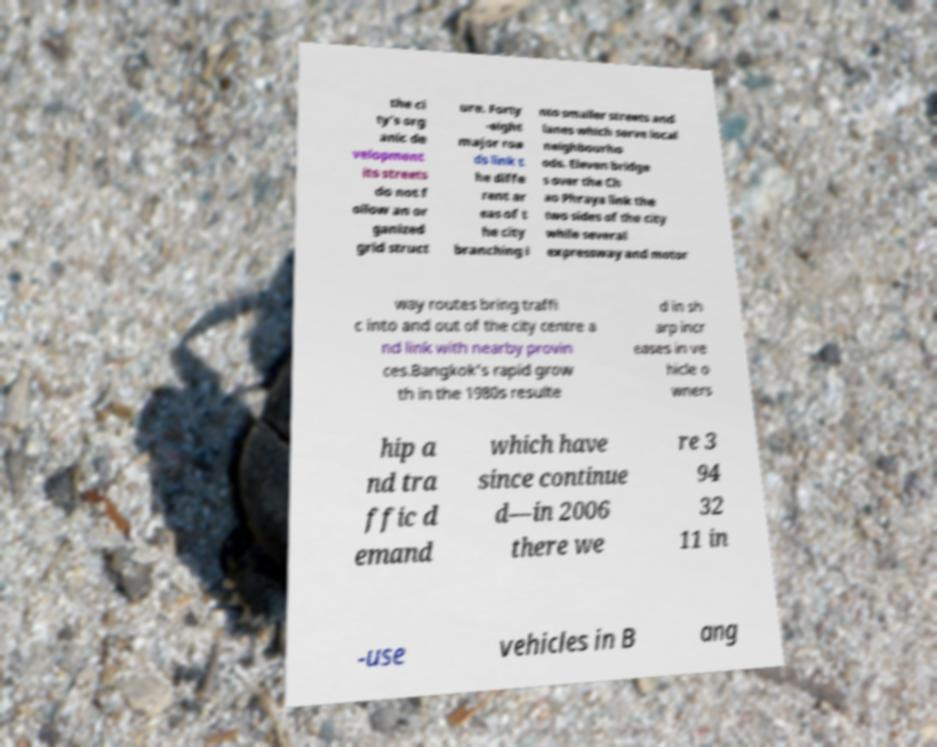For documentation purposes, I need the text within this image transcribed. Could you provide that? the ci ty's org anic de velopment its streets do not f ollow an or ganized grid struct ure. Forty -eight major roa ds link t he diffe rent ar eas of t he city branching i nto smaller streets and lanes which serve local neighbourho ods. Eleven bridge s over the Ch ao Phraya link the two sides of the city while several expressway and motor way routes bring traffi c into and out of the city centre a nd link with nearby provin ces.Bangkok's rapid grow th in the 1980s resulte d in sh arp incr eases in ve hicle o wners hip a nd tra ffic d emand which have since continue d—in 2006 there we re 3 94 32 11 in -use vehicles in B ang 